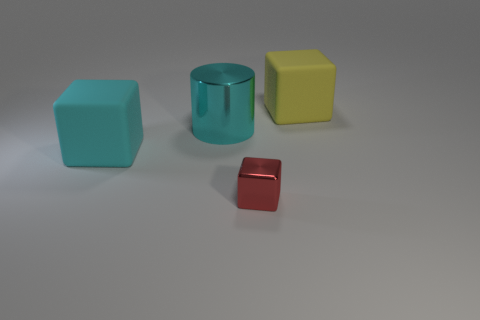What number of cyan objects are the same shape as the small red object?
Provide a short and direct response. 1. Is the number of cylinders in front of the tiny red object the same as the number of yellow matte blocks?
Offer a terse response. No. There is a cube that is the same size as the yellow matte thing; what color is it?
Provide a succinct answer. Cyan. Are there any matte things of the same shape as the cyan shiny thing?
Give a very brief answer. No. There is a large cube that is left of the big matte object right of the big cube in front of the large shiny thing; what is it made of?
Give a very brief answer. Rubber. What number of other things are the same size as the red metallic thing?
Offer a very short reply. 0. What is the color of the metal cube?
Keep it short and to the point. Red. What number of matte things are red things or big blue objects?
Your answer should be compact. 0. Are there any other things that have the same material as the yellow cube?
Your answer should be very brief. Yes. There is a matte thing in front of the rubber object that is behind the matte block that is to the left of the tiny block; what size is it?
Provide a succinct answer. Large. 